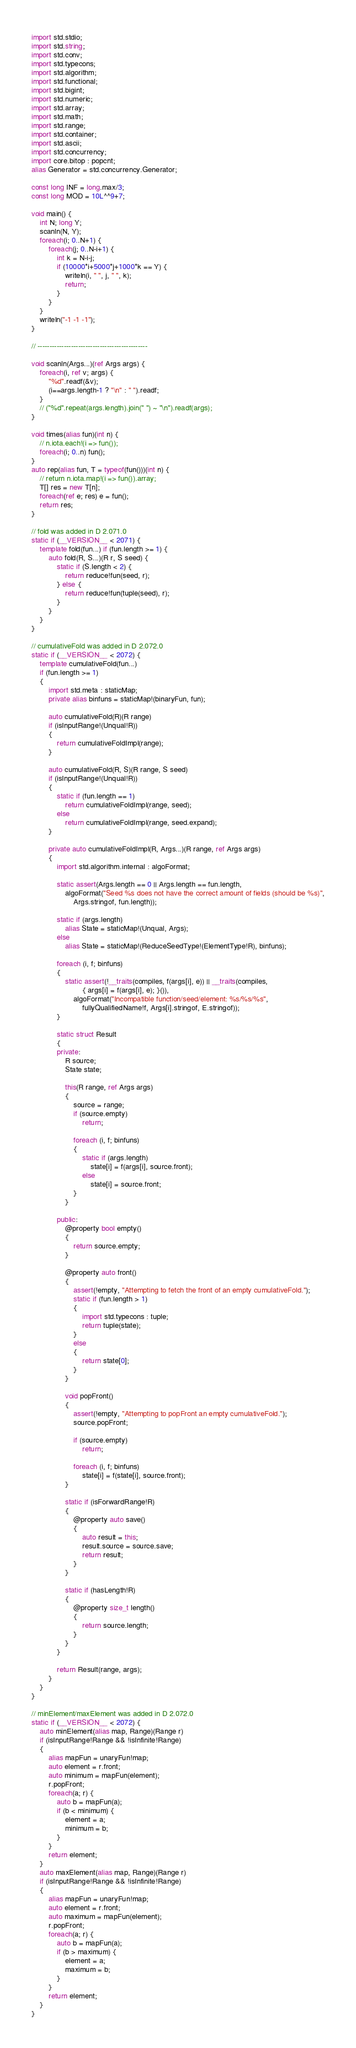<code> <loc_0><loc_0><loc_500><loc_500><_D_>import std.stdio;
import std.string;
import std.conv;
import std.typecons;
import std.algorithm;
import std.functional;
import std.bigint;
import std.numeric;
import std.array;
import std.math;
import std.range;
import std.container;
import std.ascii;
import std.concurrency;
import core.bitop : popcnt;
alias Generator = std.concurrency.Generator;

const long INF = long.max/3;
const long MOD = 10L^^9+7;

void main() {
    int N; long Y;
    scanln(N, Y);
    foreach(i; 0..N+1) {
        foreach(j; 0..N-i+1) {
            int k = N-i-j;
            if (10000*i+5000*j+1000*k == Y) {
                writeln(i, " ", j, " ", k);
                return;
            }
        }
    }
    writeln("-1 -1 -1");
}

// ----------------------------------------------

void scanln(Args...)(ref Args args) {
    foreach(i, ref v; args) {
        "%d".readf(&v);
        (i==args.length-1 ? "\n" : " ").readf;
    }
    // ("%d".repeat(args.length).join(" ") ~ "\n").readf(args);
}

void times(alias fun)(int n) {
    // n.iota.each!(i => fun());
    foreach(i; 0..n) fun();
}
auto rep(alias fun, T = typeof(fun()))(int n) {
    // return n.iota.map!(i => fun()).array;
    T[] res = new T[n];
    foreach(ref e; res) e = fun();
    return res;
}

// fold was added in D 2.071.0
static if (__VERSION__ < 2071) {
    template fold(fun...) if (fun.length >= 1) {
        auto fold(R, S...)(R r, S seed) {
            static if (S.length < 2) {
                return reduce!fun(seed, r);
            } else {
                return reduce!fun(tuple(seed), r);
            }
        }
    }
}

// cumulativeFold was added in D 2.072.0
static if (__VERSION__ < 2072) {
    template cumulativeFold(fun...)
    if (fun.length >= 1)
    {
        import std.meta : staticMap;
        private alias binfuns = staticMap!(binaryFun, fun);

        auto cumulativeFold(R)(R range)
        if (isInputRange!(Unqual!R))
        {
            return cumulativeFoldImpl(range);
        }

        auto cumulativeFold(R, S)(R range, S seed)
        if (isInputRange!(Unqual!R))
        {
            static if (fun.length == 1)
                return cumulativeFoldImpl(range, seed);
            else
                return cumulativeFoldImpl(range, seed.expand);
        }

        private auto cumulativeFoldImpl(R, Args...)(R range, ref Args args)
        {
            import std.algorithm.internal : algoFormat;

            static assert(Args.length == 0 || Args.length == fun.length,
                algoFormat("Seed %s does not have the correct amount of fields (should be %s)",
                    Args.stringof, fun.length));

            static if (args.length)
                alias State = staticMap!(Unqual, Args);
            else
                alias State = staticMap!(ReduceSeedType!(ElementType!R), binfuns);

            foreach (i, f; binfuns)
            {
                static assert(!__traits(compiles, f(args[i], e)) || __traits(compiles,
                        { args[i] = f(args[i], e); }()),
                    algoFormat("Incompatible function/seed/element: %s/%s/%s",
                        fullyQualifiedName!f, Args[i].stringof, E.stringof));
            }

            static struct Result
            {
            private:
                R source;
                State state;

                this(R range, ref Args args)
                {
                    source = range;
                    if (source.empty)
                        return;

                    foreach (i, f; binfuns)
                    {
                        static if (args.length)
                            state[i] = f(args[i], source.front);
                        else
                            state[i] = source.front;
                    }
                }

            public:
                @property bool empty()
                {
                    return source.empty;
                }

                @property auto front()
                {
                    assert(!empty, "Attempting to fetch the front of an empty cumulativeFold.");
                    static if (fun.length > 1)
                    {
                        import std.typecons : tuple;
                        return tuple(state);
                    }
                    else
                    {
                        return state[0];
                    }
                }

                void popFront()
                {
                    assert(!empty, "Attempting to popFront an empty cumulativeFold.");
                    source.popFront;

                    if (source.empty)
                        return;

                    foreach (i, f; binfuns)
                        state[i] = f(state[i], source.front);
                }

                static if (isForwardRange!R)
                {
                    @property auto save()
                    {
                        auto result = this;
                        result.source = source.save;
                        return result;
                    }
                }

                static if (hasLength!R)
                {
                    @property size_t length()
                    {
                        return source.length;
                    }
                }
            }

            return Result(range, args);
        }
    }
}

// minElement/maxElement was added in D 2.072.0
static if (__VERSION__ < 2072) {
    auto minElement(alias map, Range)(Range r)
    if (isInputRange!Range && !isInfinite!Range)
    {
        alias mapFun = unaryFun!map;
        auto element = r.front;
        auto minimum = mapFun(element);
        r.popFront;
        foreach(a; r) {
            auto b = mapFun(a);
            if (b < minimum) {
                element = a;
                minimum = b;
            }
        }
        return element;
    }
    auto maxElement(alias map, Range)(Range r)
    if (isInputRange!Range && !isInfinite!Range)
    {
        alias mapFun = unaryFun!map;
        auto element = r.front;
        auto maximum = mapFun(element);
        r.popFront;
        foreach(a; r) {
            auto b = mapFun(a);
            if (b > maximum) {
                element = a;
                maximum = b;
            }
        }
        return element;
    }
}
</code> 